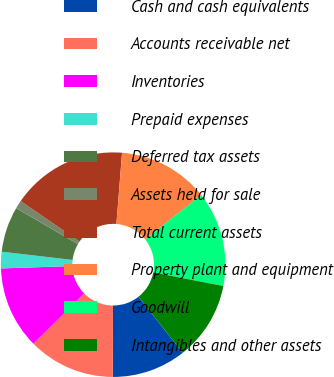Convert chart. <chart><loc_0><loc_0><loc_500><loc_500><pie_chart><fcel>Cash and cash equivalents<fcel>Accounts receivable net<fcel>Inventories<fcel>Prepaid expenses<fcel>Deferred tax assets<fcel>Assets held for sale<fcel>Total current assets<fcel>Property plant and equipment<fcel>Goodwill<fcel>Intangibles and other assets<nl><fcel>10.71%<fcel>12.5%<fcel>11.9%<fcel>2.38%<fcel>6.55%<fcel>1.19%<fcel>16.67%<fcel>13.09%<fcel>13.69%<fcel>11.31%<nl></chart> 